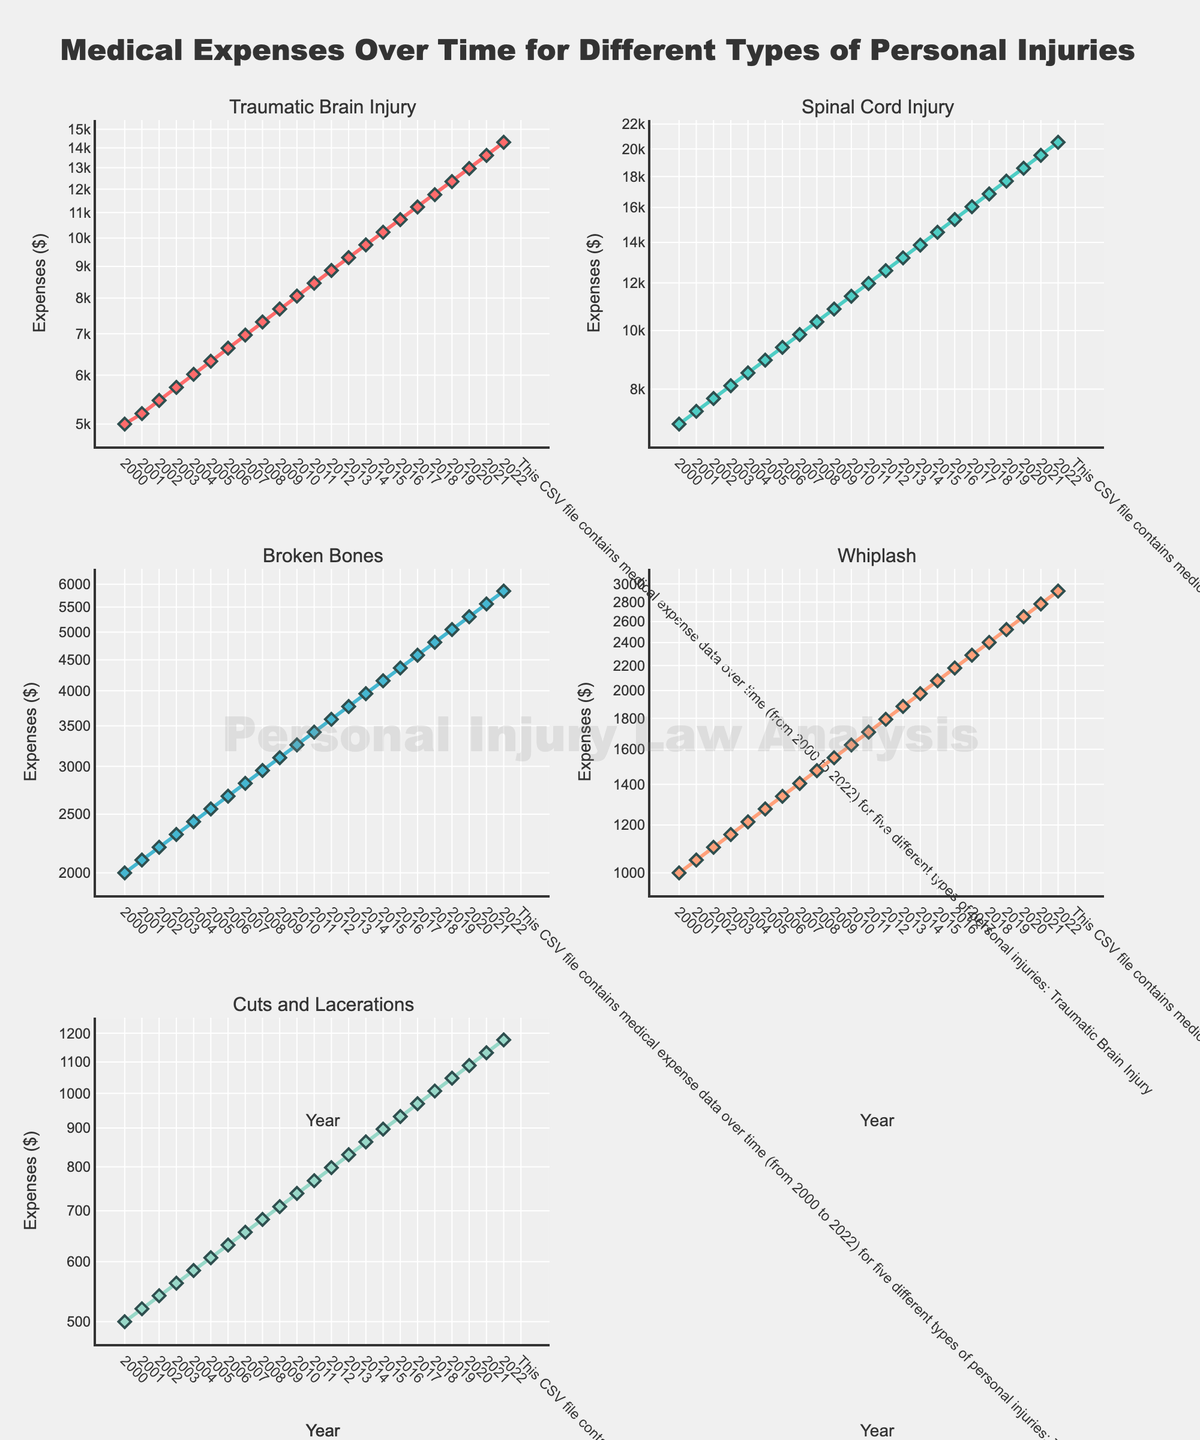How does the medical expense for Spinal Cord Injury in 2022 compare to that in 2000? To find the difference, check the costs for Spinal Cord Injury in both years from the plot. In 2000, the expense is around 7000, and in 2022, it is around 20515. So, the increase is 20515 - 7000 = 13515.
Answer: 13515 Which type of injury has the steepest rise in expenses over the 22 years? By observing the slopes of the lines in each subplot, the steeper the line, the greater the rise in expenses. Traumatic Brain Injury has the steepest slope, indicating the steepest rise.
Answer: Traumatic Brain Injury By what factor did the expenses for Whiplash increase from 2005 to 2020? Identify the expenses for Whiplash in 2005 (1275) and 2020 (2648) from the plot. The factor is calculated as 2648 / 1275 ≈ 2.08.
Answer: 2.08 What is the relationship between expenses for Broken Bones and Cuts and Lacerations in 2010? Compare the expenses in 2010 for both injuries. Broken Bones expense is around 3255, while Cuts and Lacerations expense is around 738. Broken Bones has significantly higher costs.
Answer: Broken Bones are greater Which injury type had the least expense in 2020, and what was that amount? Observe the plot for 2020. Cuts and Lacerations had the least expense, around 1088.
Answer: Cuts and Lacerations, 1088 Are the expenses for Traumatic Brain Injury in 2009 closer to those for Spinal Cord Injury in 2005 or Broken Bones in 2010? Check the expenses: Traumatic Brain Injury in 2009 (7678), Spinal Cord Injury in 2005 (8935), and Broken Bones in 2010 (3255). Calculate the differences: 7678 - 8935 ≈ -1257 and 7678 - 3255 ≈ 4423. Traumatic Brain Injury in 2009 is closer to Spinal Cord Injury in 2005.
Answer: Spinal Cord Injury in 2005 On a log scale, which injury type shows the most consistent increase in expense over the years? By examining how straight the lines are on the log scale, Whiplash shows the most consistent increase as its line is the most consistently smooth.
Answer: Whiplash What year did Spinal Cord Injury expenses surpass $10,000? Observe the Spinal Cord Injury plot and locate the year when the expense first exceeds $10,000. It is in 2009.
Answer: 2009 How much more were the expenses for Traumatic Brain Injury than Whiplash in 2022? Identify the values for both injuries in 2022. Traumatic Brain Injury is around 14291, and Whiplash is around 2919. The difference is 14291 - 2919 ≈ 11372.
Answer: 11372 What is the average annual increase in expense for Broken Bones from 2000 to 2022? Calculate the total increase (5844 - 2000 = 3844) and divide by the number of years (22). The average increase per year is 3844 / 22 ≈ 174.73.
Answer: 174.73 